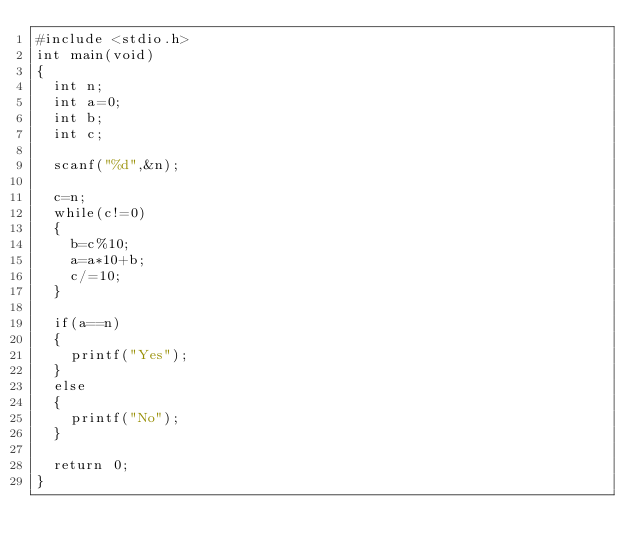Convert code to text. <code><loc_0><loc_0><loc_500><loc_500><_C_>#include <stdio.h>
int main(void)
{
  int n;
  int a=0;
  int b;
  int c;

  scanf("%d",&n);

  c=n;
  while(c!=0)
  {
    b=c%10;
    a=a*10+b;
    c/=10;
  }

  if(a==n)
  {
    printf("Yes");
  }
  else
  {
    printf("No");
  }

  return 0;
}
</code> 